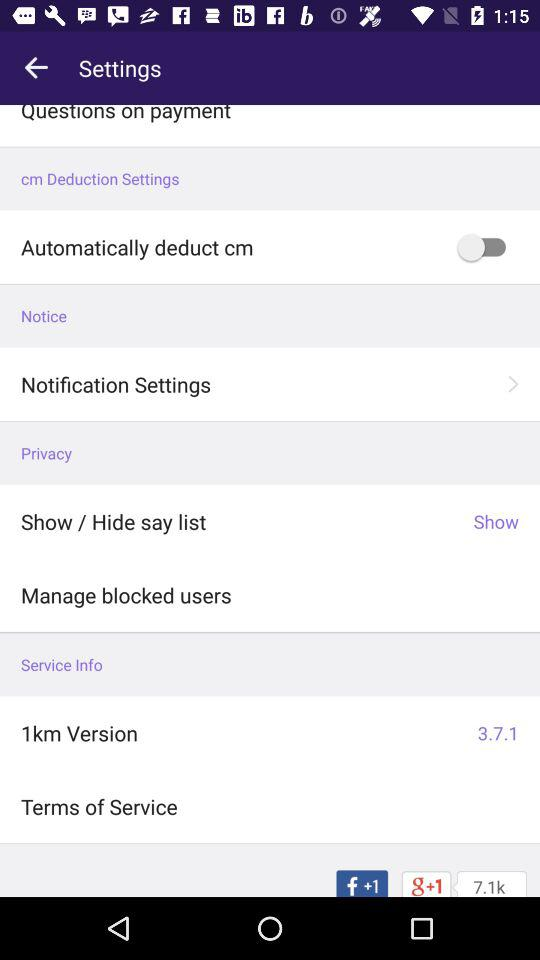What is the version of "1km"? The version of "1km" is 3.7.1. 